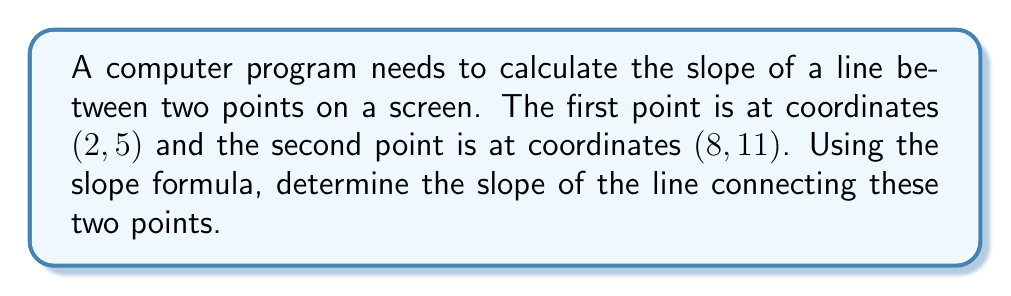Can you solve this math problem? To find the slope of a line using two points, we use the slope formula:

$$ m = \frac{y_2 - y_1}{x_2 - x_1} $$

Where $(x_1, y_1)$ is the first point and $(x_2, y_2)$ is the second point.

Given:
- Point 1: $(x_1, y_1) = (2, 5)$
- Point 2: $(x_2, y_2) = (8, 11)$

Let's substitute these values into the formula:

$$ m = \frac{11 - 5}{8 - 2} $$

Simplify the numerator and denominator:

$$ m = \frac{6}{6} $$

Perform the division:

$$ m = 1 $$

Therefore, the slope of the line connecting the two points is 1.
Answer: $1$ 